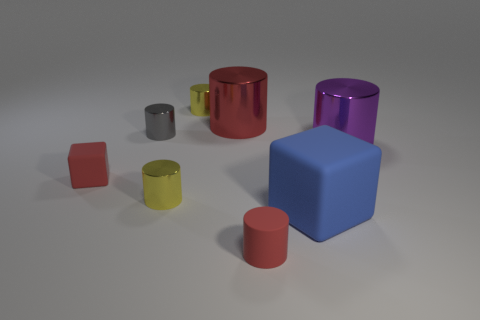Subtract all tiny cylinders. How many cylinders are left? 2 Add 1 small red things. How many objects exist? 9 Subtract 2 blocks. How many blocks are left? 0 Subtract all blue blocks. How many blocks are left? 1 Subtract all blocks. How many objects are left? 6 Subtract all green cylinders. Subtract all cyan spheres. How many cylinders are left? 6 Subtract all brown cylinders. How many purple cubes are left? 0 Subtract all large purple shiny blocks. Subtract all blue things. How many objects are left? 7 Add 8 big rubber blocks. How many big rubber blocks are left? 9 Add 3 small brown shiny things. How many small brown shiny things exist? 3 